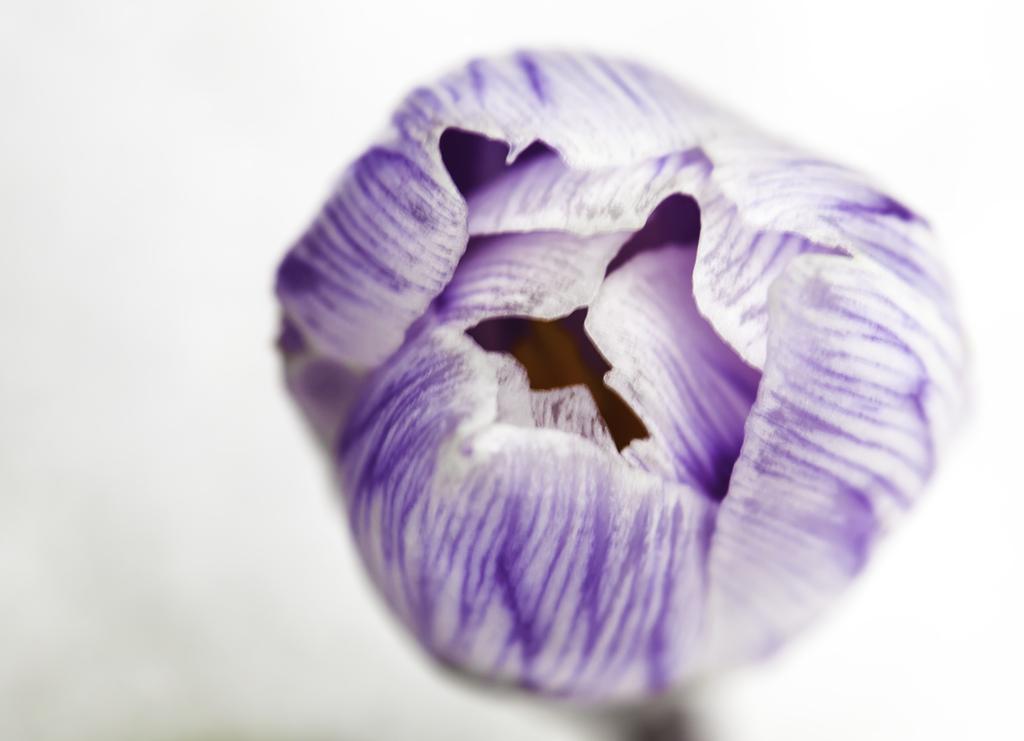Please provide a concise description of this image. The picture consists of a flower with violet and white petals. The picture has white blurred background. 